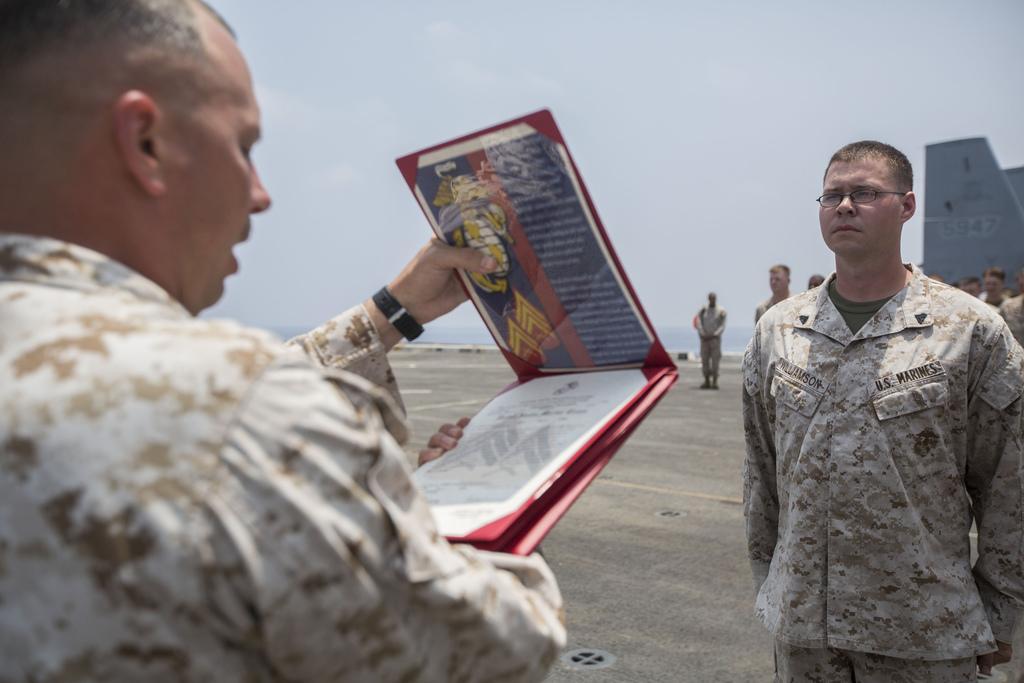Describe this image in one or two sentences. In this image there are two persons standing , a person holding a book , and in the background there are group of people standing, water, sky. 